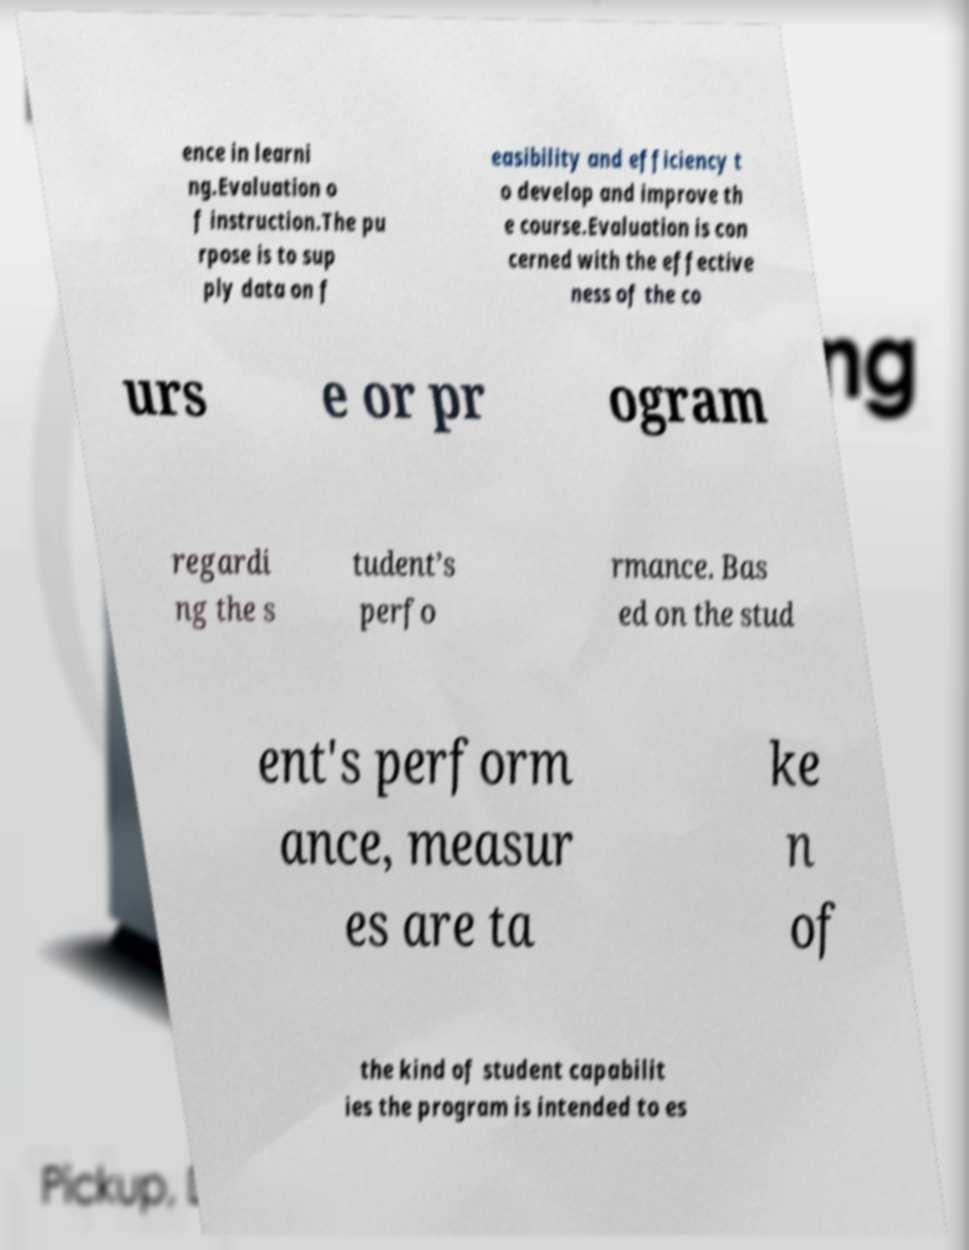Please read and relay the text visible in this image. What does it say? ence in learni ng.Evaluation o f instruction.The pu rpose is to sup ply data on f easibility and efficiency t o develop and improve th e course.Evaluation is con cerned with the effective ness of the co urs e or pr ogram regardi ng the s tudent’s perfo rmance. Bas ed on the stud ent's perform ance, measur es are ta ke n of the kind of student capabilit ies the program is intended to es 